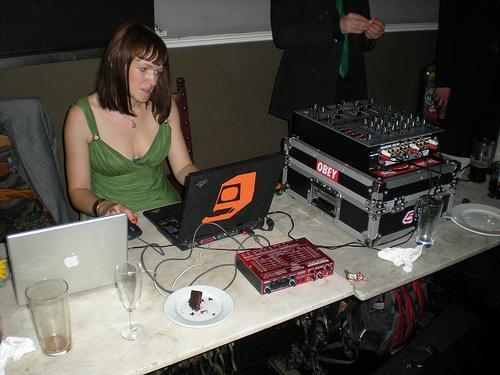How many champagne type glasses are on the table on the left?
Give a very brief answer. 1. 